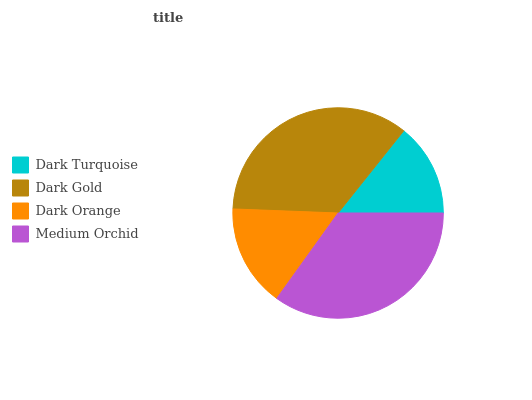Is Dark Turquoise the minimum?
Answer yes or no. Yes. Is Dark Gold the maximum?
Answer yes or no. Yes. Is Dark Orange the minimum?
Answer yes or no. No. Is Dark Orange the maximum?
Answer yes or no. No. Is Dark Gold greater than Dark Orange?
Answer yes or no. Yes. Is Dark Orange less than Dark Gold?
Answer yes or no. Yes. Is Dark Orange greater than Dark Gold?
Answer yes or no. No. Is Dark Gold less than Dark Orange?
Answer yes or no. No. Is Medium Orchid the high median?
Answer yes or no. Yes. Is Dark Orange the low median?
Answer yes or no. Yes. Is Dark Orange the high median?
Answer yes or no. No. Is Dark Turquoise the low median?
Answer yes or no. No. 